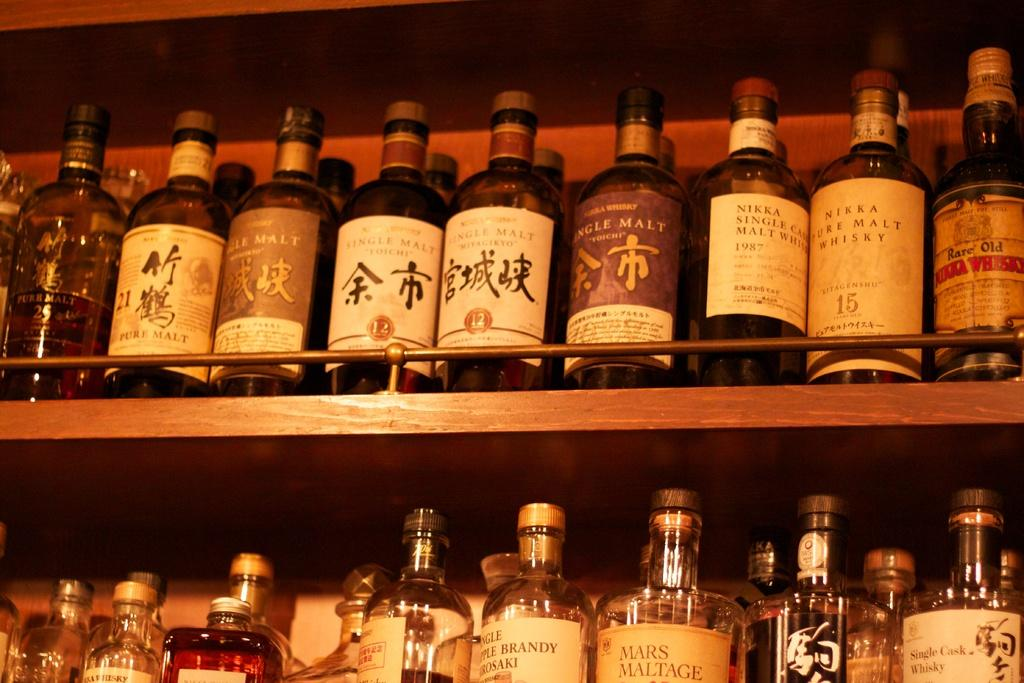What can be seen in the image that might be used for storage? There is a shelf in the image that can be used for storage. What items are stored on the shelf? Wine bottles are present on the shelf. What language is spoken by the bottles on the shelf in the image? The bottles on the shelf do not speak a language, as they are inanimate objects. 